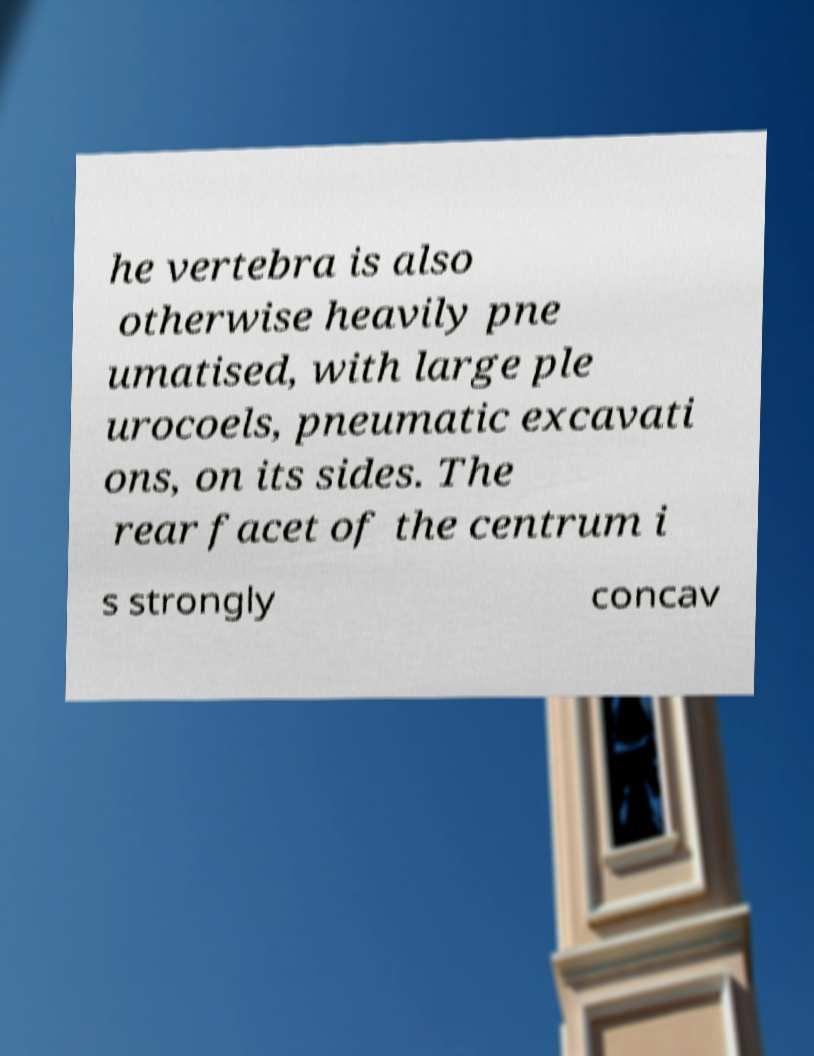What messages or text are displayed in this image? I need them in a readable, typed format. he vertebra is also otherwise heavily pne umatised, with large ple urocoels, pneumatic excavati ons, on its sides. The rear facet of the centrum i s strongly concav 